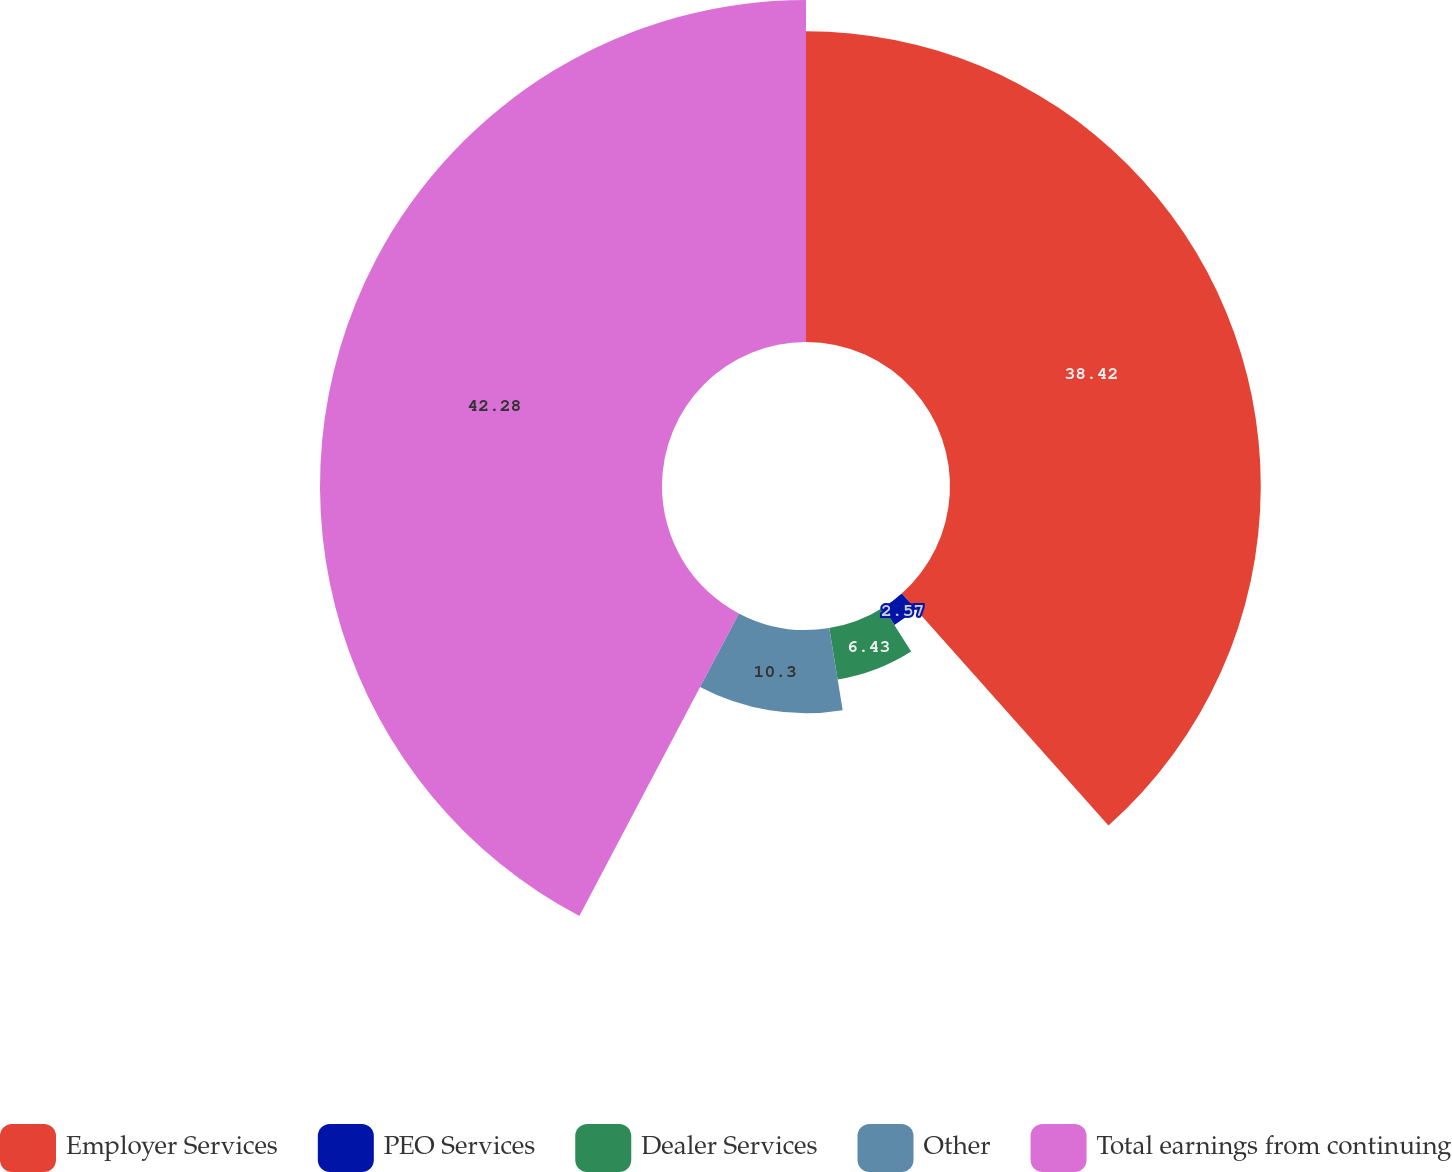Convert chart to OTSL. <chart><loc_0><loc_0><loc_500><loc_500><pie_chart><fcel>Employer Services<fcel>PEO Services<fcel>Dealer Services<fcel>Other<fcel>Total earnings from continuing<nl><fcel>38.42%<fcel>2.57%<fcel>6.43%<fcel>10.3%<fcel>42.28%<nl></chart> 